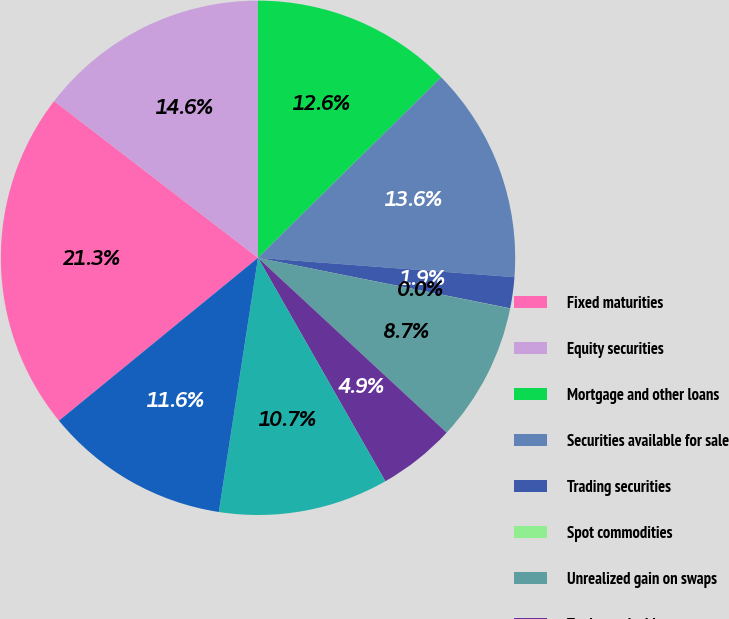<chart> <loc_0><loc_0><loc_500><loc_500><pie_chart><fcel>Fixed maturities<fcel>Equity securities<fcel>Mortgage and other loans<fcel>Securities available for sale<fcel>Trading securities<fcel>Spot commodities<fcel>Unrealized gain on swaps<fcel>Trade receivables<fcel>Securities purchased under<fcel>Finance receivables net of<nl><fcel>21.35%<fcel>14.56%<fcel>12.62%<fcel>13.59%<fcel>1.95%<fcel>0.01%<fcel>8.74%<fcel>4.86%<fcel>10.68%<fcel>11.65%<nl></chart> 